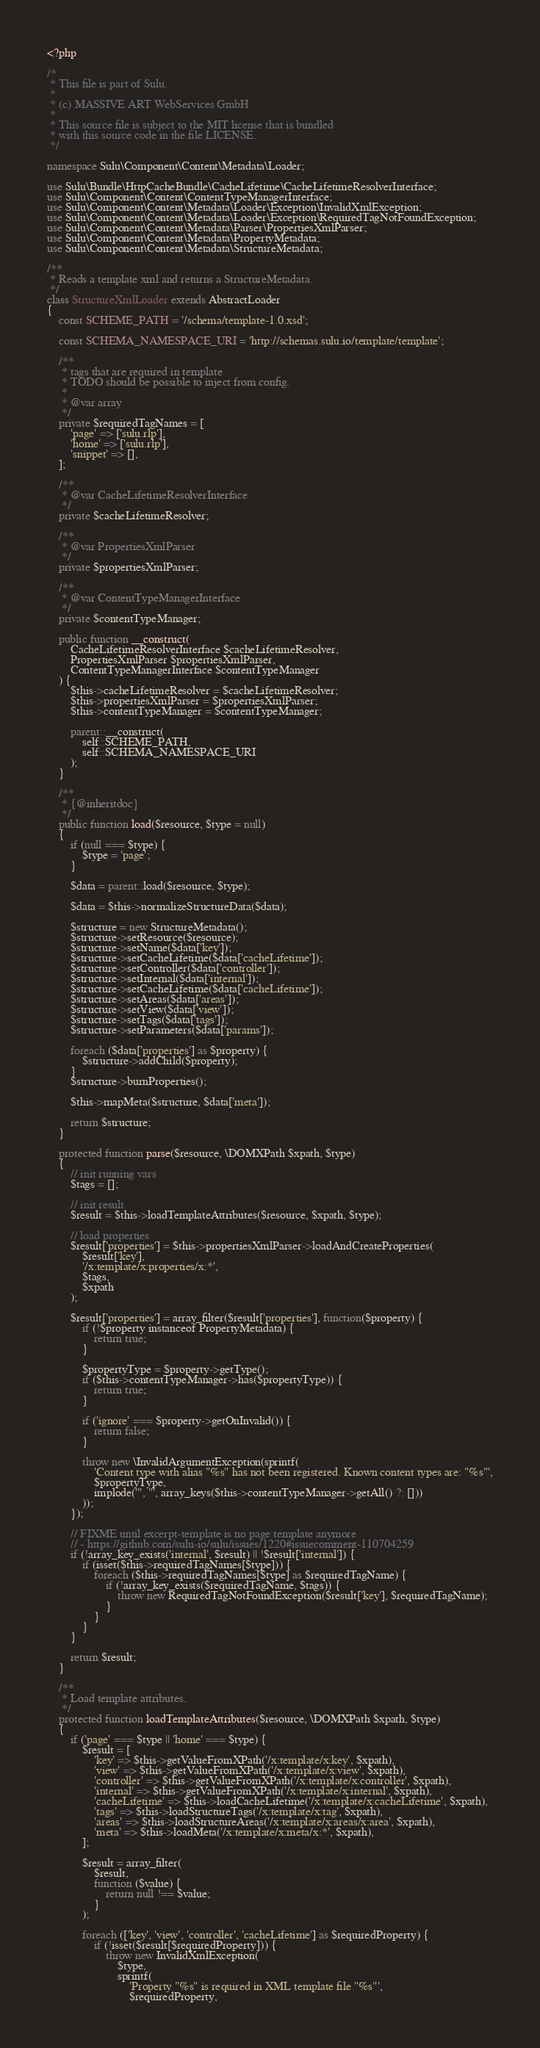<code> <loc_0><loc_0><loc_500><loc_500><_PHP_><?php

/*
 * This file is part of Sulu.
 *
 * (c) MASSIVE ART WebServices GmbH
 *
 * This source file is subject to the MIT license that is bundled
 * with this source code in the file LICENSE.
 */

namespace Sulu\Component\Content\Metadata\Loader;

use Sulu\Bundle\HttpCacheBundle\CacheLifetime\CacheLifetimeResolverInterface;
use Sulu\Component\Content\ContentTypeManagerInterface;
use Sulu\Component\Content\Metadata\Loader\Exception\InvalidXmlException;
use Sulu\Component\Content\Metadata\Loader\Exception\RequiredTagNotFoundException;
use Sulu\Component\Content\Metadata\Parser\PropertiesXmlParser;
use Sulu\Component\Content\Metadata\PropertyMetadata;
use Sulu\Component\Content\Metadata\StructureMetadata;

/**
 * Reads a template xml and returns a StructureMetadata.
 */
class StructureXmlLoader extends AbstractLoader
{
    const SCHEME_PATH = '/schema/template-1.0.xsd';

    const SCHEMA_NAMESPACE_URI = 'http://schemas.sulu.io/template/template';

    /**
     * tags that are required in template
     * TODO should be possible to inject from config.
     *
     * @var array
     */
    private $requiredTagNames = [
        'page' => ['sulu.rlp'],
        'home' => ['sulu.rlp'],
        'snippet' => [],
    ];

    /**
     * @var CacheLifetimeResolverInterface
     */
    private $cacheLifetimeResolver;

    /**
     * @var PropertiesXmlParser
     */
    private $propertiesXmlParser;

    /**
     * @var ContentTypeManagerInterface
     */
    private $contentTypeManager;

    public function __construct(
        CacheLifetimeResolverInterface $cacheLifetimeResolver,
        PropertiesXmlParser $propertiesXmlParser,
        ContentTypeManagerInterface $contentTypeManager
    ) {
        $this->cacheLifetimeResolver = $cacheLifetimeResolver;
        $this->propertiesXmlParser = $propertiesXmlParser;
        $this->contentTypeManager = $contentTypeManager;

        parent::__construct(
            self::SCHEME_PATH,
            self::SCHEMA_NAMESPACE_URI
        );
    }

    /**
     * {@inheritdoc}
     */
    public function load($resource, $type = null)
    {
        if (null === $type) {
            $type = 'page';
        }

        $data = parent::load($resource, $type);

        $data = $this->normalizeStructureData($data);

        $structure = new StructureMetadata();
        $structure->setResource($resource);
        $structure->setName($data['key']);
        $structure->setCacheLifetime($data['cacheLifetime']);
        $structure->setController($data['controller']);
        $structure->setInternal($data['internal']);
        $structure->setCacheLifetime($data['cacheLifetime']);
        $structure->setAreas($data['areas']);
        $structure->setView($data['view']);
        $structure->setTags($data['tags']);
        $structure->setParameters($data['params']);

        foreach ($data['properties'] as $property) {
            $structure->addChild($property);
        }
        $structure->burnProperties();

        $this->mapMeta($structure, $data['meta']);

        return $structure;
    }

    protected function parse($resource, \DOMXPath $xpath, $type)
    {
        // init running vars
        $tags = [];

        // init result
        $result = $this->loadTemplateAttributes($resource, $xpath, $type);

        // load properties
        $result['properties'] = $this->propertiesXmlParser->loadAndCreateProperties(
            $result['key'],
            '/x:template/x:properties/x:*',
            $tags,
            $xpath
        );

        $result['properties'] = array_filter($result['properties'], function($property) {
            if (!$property instanceof PropertyMetadata) {
                return true;
            }

            $propertyType = $property->getType();
            if ($this->contentTypeManager->has($propertyType)) {
                return true;
            }

            if ('ignore' === $property->getOnInvalid()) {
                return false;
            }

            throw new \InvalidArgumentException(sprintf(
                'Content type with alias "%s" has not been registered. Known content types are: "%s"',
                $propertyType,
                implode('", "', array_keys($this->contentTypeManager->getAll() ?: []))
            ));
        });

        // FIXME until excerpt-template is no page template anymore
        // - https://github.com/sulu-io/sulu/issues/1220#issuecomment-110704259
        if (!array_key_exists('internal', $result) || !$result['internal']) {
            if (isset($this->requiredTagNames[$type])) {
                foreach ($this->requiredTagNames[$type] as $requiredTagName) {
                    if (!array_key_exists($requiredTagName, $tags)) {
                        throw new RequiredTagNotFoundException($result['key'], $requiredTagName);
                    }
                }
            }
        }

        return $result;
    }

    /**
     * Load template attributes.
     */
    protected function loadTemplateAttributes($resource, \DOMXPath $xpath, $type)
    {
        if ('page' === $type || 'home' === $type) {
            $result = [
                'key' => $this->getValueFromXPath('/x:template/x:key', $xpath),
                'view' => $this->getValueFromXPath('/x:template/x:view', $xpath),
                'controller' => $this->getValueFromXPath('/x:template/x:controller', $xpath),
                'internal' => $this->getValueFromXPath('/x:template/x:internal', $xpath),
                'cacheLifetime' => $this->loadCacheLifetime('/x:template/x:cacheLifetime', $xpath),
                'tags' => $this->loadStructureTags('/x:template/x:tag', $xpath),
                'areas' => $this->loadStructureAreas('/x:template/x:areas/x:area', $xpath),
                'meta' => $this->loadMeta('/x:template/x:meta/x:*', $xpath),
            ];

            $result = array_filter(
                $result,
                function ($value) {
                    return null !== $value;
                }
            );

            foreach (['key', 'view', 'controller', 'cacheLifetime'] as $requiredProperty) {
                if (!isset($result[$requiredProperty])) {
                    throw new InvalidXmlException(
                        $type,
                        sprintf(
                            'Property "%s" is required in XML template file "%s"',
                            $requiredProperty,</code> 